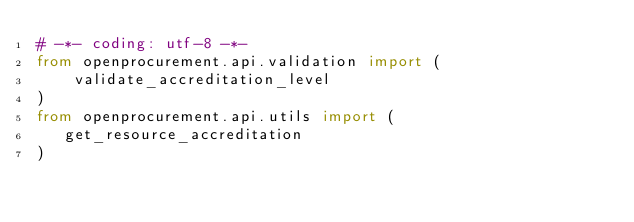Convert code to text. <code><loc_0><loc_0><loc_500><loc_500><_Python_># -*- coding: utf-8 -*-
from openprocurement.api.validation import (
    validate_accreditation_level
)
from openprocurement.api.utils import (
   get_resource_accreditation
)

</code> 